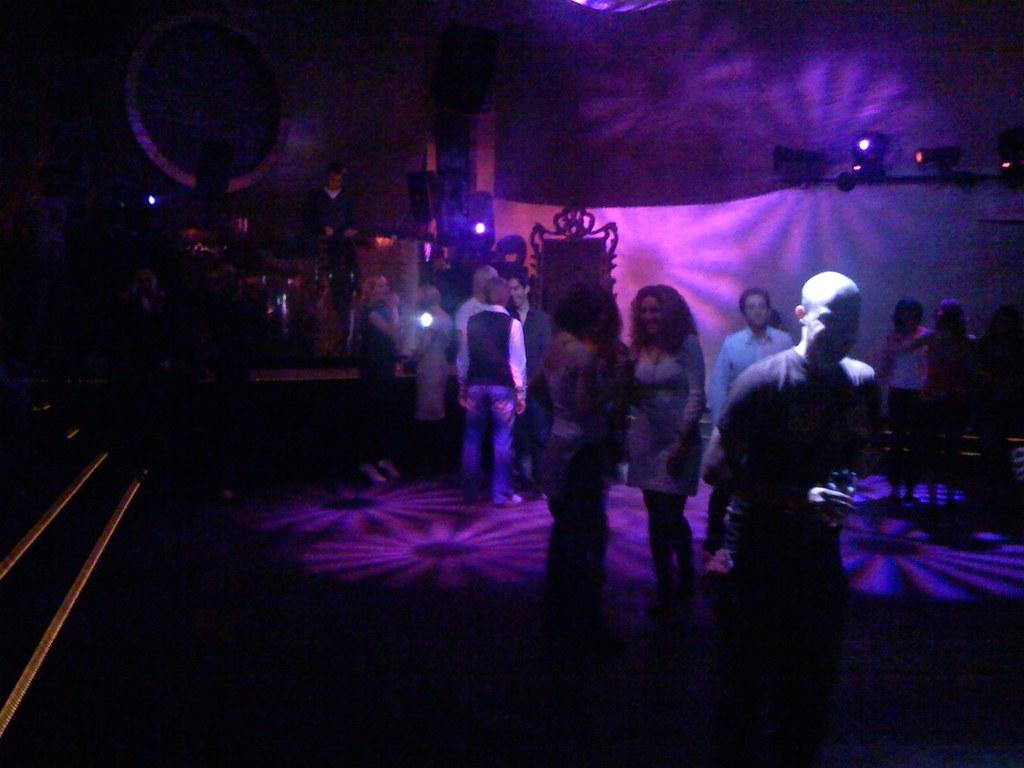Who or what is present in the image? There are people in the image. What can be seen illuminating the scene? There are lights in the image. What else can be observed besides the people and lights? There are other objects in the image. What is the surface that the people and objects are standing on or near? There is a floor at the bottom of the image. What type of food is being prepared on the thread in the image? There is no thread or food preparation visible in the image. 